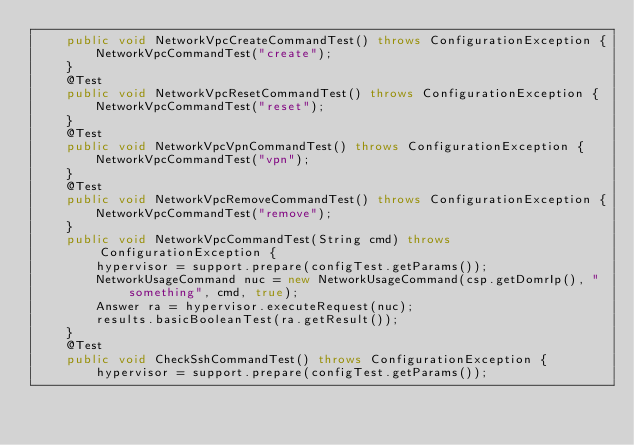Convert code to text. <code><loc_0><loc_0><loc_500><loc_500><_Java_>    public void NetworkVpcCreateCommandTest() throws ConfigurationException {
        NetworkVpcCommandTest("create");
    }
    @Test
    public void NetworkVpcResetCommandTest() throws ConfigurationException {
        NetworkVpcCommandTest("reset");
    }
    @Test
    public void NetworkVpcVpnCommandTest() throws ConfigurationException {
        NetworkVpcCommandTest("vpn");
    }
    @Test
    public void NetworkVpcRemoveCommandTest() throws ConfigurationException {
        NetworkVpcCommandTest("remove");
    }
    public void NetworkVpcCommandTest(String cmd) throws ConfigurationException {
        hypervisor = support.prepare(configTest.getParams());
        NetworkUsageCommand nuc = new NetworkUsageCommand(csp.getDomrIp(), "something", cmd, true);
        Answer ra = hypervisor.executeRequest(nuc);
        results.basicBooleanTest(ra.getResult());
    }
    @Test
    public void CheckSshCommandTest() throws ConfigurationException {
        hypervisor = support.prepare(configTest.getParams());</code> 